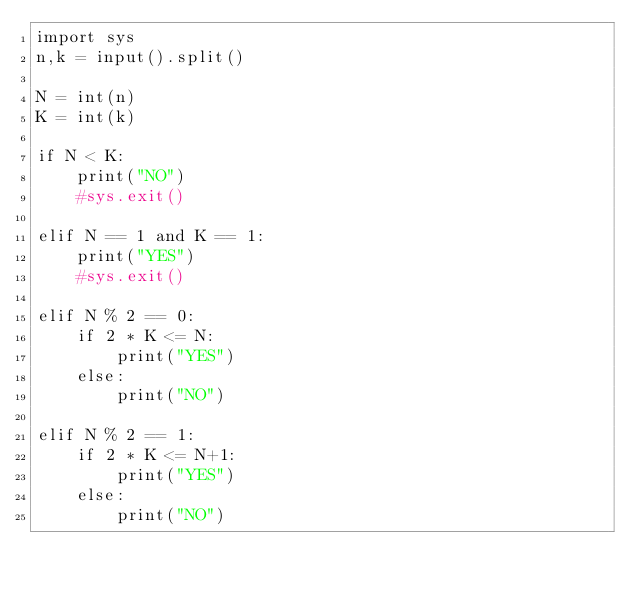Convert code to text. <code><loc_0><loc_0><loc_500><loc_500><_Python_>import sys
n,k = input().split()

N = int(n)
K = int(k)

if N < K:
    print("NO")
    #sys.exit()
    
elif N == 1 and K == 1:
    print("YES")
    #sys.exit()

elif N % 2 == 0:
    if 2 * K <= N:
        print("YES")
    else:
        print("NO")

elif N % 2 == 1:
    if 2 * K <= N+1:
        print("YES")
    else:
        print("NO")</code> 